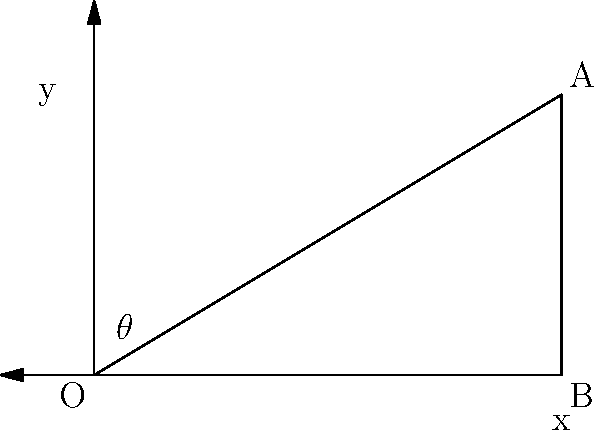In a simple physics-based game, you need to determine the angle of trajectory for a projectile. Given that the projectile starts at point O (0,0) and needs to hit a target at point A (5,3), what is the angle $\theta$ (in degrees) between the x-axis and the trajectory? To solve this problem, we'll follow these steps:

1. Identify the right triangle formed by points O, A, and B.
2. Calculate the opposite and adjacent sides of the triangle.
3. Use the arctangent function to determine the angle.

Step 1: The right triangle is formed by OAB, where OB is the adjacent side and BA is the opposite side.

Step 2: Calculate the lengths of the sides:
- Adjacent side (OB) = 5 units (x-coordinate of point A)
- Opposite side (BA) = 3 units (y-coordinate of point A)

Step 3: Use the arctangent function to calculate the angle:

$\theta = \arctan(\frac{\text{opposite}}{\text{adjacent}})$

$\theta = \arctan(\frac{3}{5})$

$\theta = \arctan(0.6)$

Using a calculator or programming function:

$\theta \approx 30.96375653207352$ degrees

Rounding to two decimal places:

$\theta \approx 30.96$ degrees

This angle represents the trajectory needed for the projectile to hit the target at point A.
Answer: $30.96°$ 